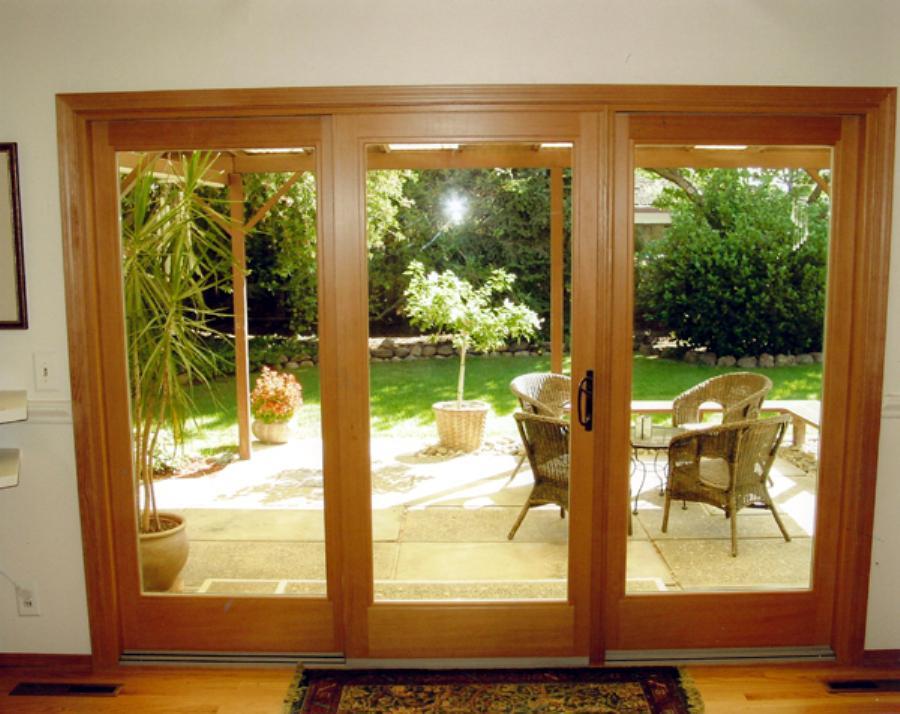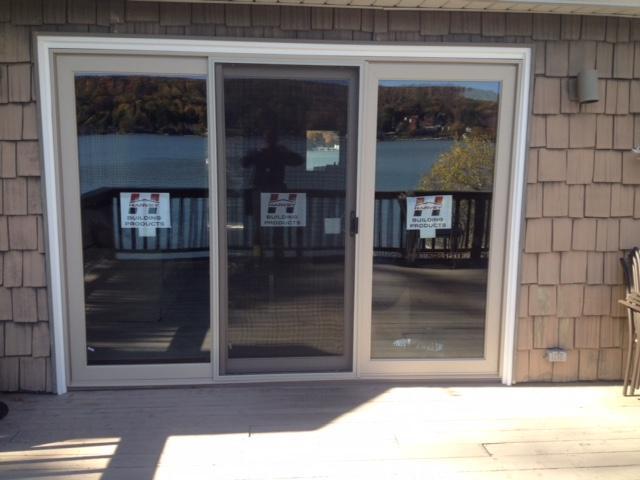The first image is the image on the left, the second image is the image on the right. For the images displayed, is the sentence "An image shows a square sliding glass unit with just two side-by-side glass panes." factually correct? Answer yes or no. No. The first image is the image on the left, the second image is the image on the right. Assess this claim about the two images: "One door frame is white and the other is black.". Correct or not? Answer yes or no. No. 